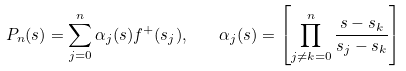Convert formula to latex. <formula><loc_0><loc_0><loc_500><loc_500>P _ { n } ( s ) = \sum _ { j = 0 } ^ { n } \alpha _ { j } ( s ) f ^ { + } ( s _ { j } ) , \quad \alpha _ { j } ( s ) = \left [ \prod _ { j \ne k = 0 } ^ { n } \frac { s - s _ { k } } { s _ { j } - s _ { k } } \right ]</formula> 